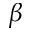<formula> <loc_0><loc_0><loc_500><loc_500>\beta</formula> 